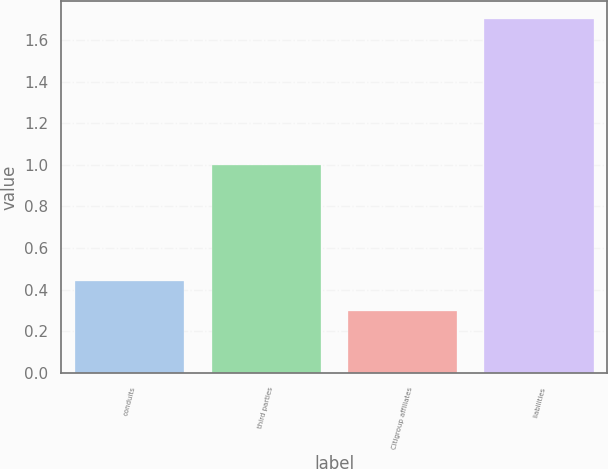Convert chart to OTSL. <chart><loc_0><loc_0><loc_500><loc_500><bar_chart><fcel>conduits<fcel>third parties<fcel>Citigroup affiliates<fcel>liabilities<nl><fcel>0.44<fcel>1<fcel>0.3<fcel>1.7<nl></chart> 